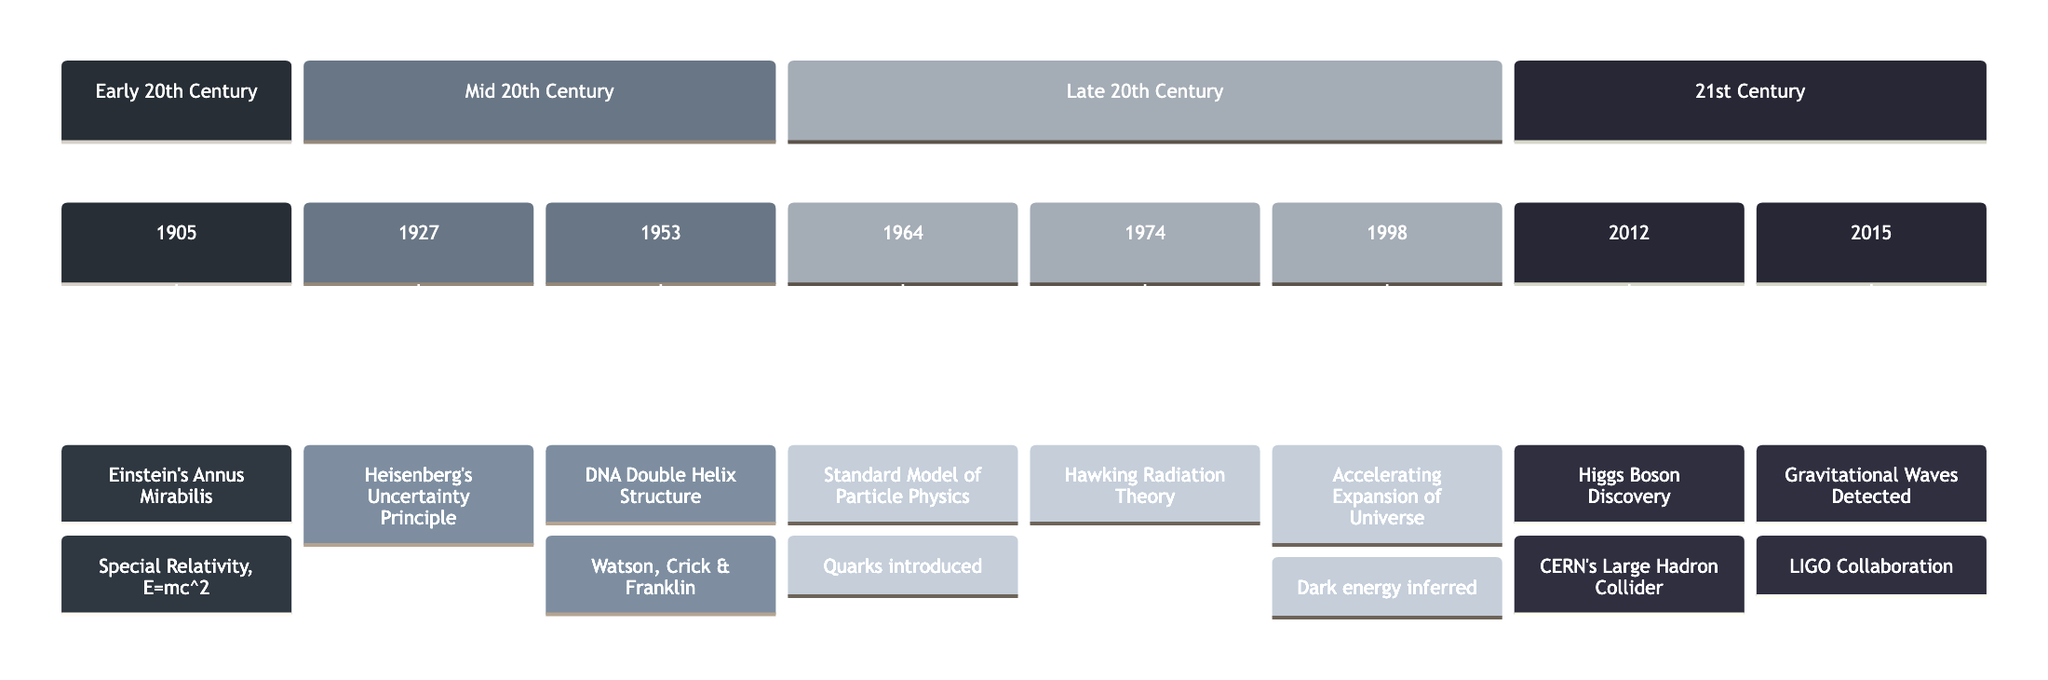What year did Einstein publish his groundbreaking papers? The timeline indicates the year 1905 as the point when Einstein published his notable works, thus directly identifying that year.
Answer: 1905 What event occurred in 1953? The timeline lists the event that took place in 1953 as the discovery of DNA’s Double Helix structure, mentioned alongside important contributors.
Answer: Discovery of DNA’s Double Helix Structure How many major scientific events are represented in the timeline? By counting the individual entries in the timeline from 1905 through to 2015, we find a total of eight distinct events noted within this period.
Answer: Eight Which scientific theory was introduced in 1974? The timeline clearly presents that in 1974, the Hawking Radiation Theory was proposed, indicating its significance in theoretical physics.
Answer: Hawking Radiation Theory What fundamental concept was introduced in 1964? The event from 1964 indicates the introduction of the Standard Model of Particle Physics, specifically highlighting the emergence of quarks, an essential concept in particle physics.
Answer: Standard Model of Particle Physics What discovery was made by the LIGO Scientific Collaboration? According to the timeline, the first detection of gravitational waves was achieved by this collaboration, confirming a critical prediction of Einstein's General Theory of Relativity.
Answer: First Detection of Gravitational Waves In which section of the timeline is the discovery of the Higgs Boson placed? The timeline organizes events by century segments, specifically placing the Higgs Boson discovery in the 21st Century section based on the event year of 2012.
Answer: 21st Century What topic connects the events from 1998 and 2012? Both events reference developments in cosmology and particle physics; one relates to the discovery of dark energy related to the expanding universe, while the other pertains to the Higgs boson connected to mass, suggesting an evolution of understanding in physics.
Answer: Dark energy and Higgs boson Which year marks the onset of the Mid 20th Century scientific developments? The timeline defines the Mid 20th Century with the event in 1927 as a distinguishing point, therefore the year marking the onset would be 1927 itself.
Answer: 1927 